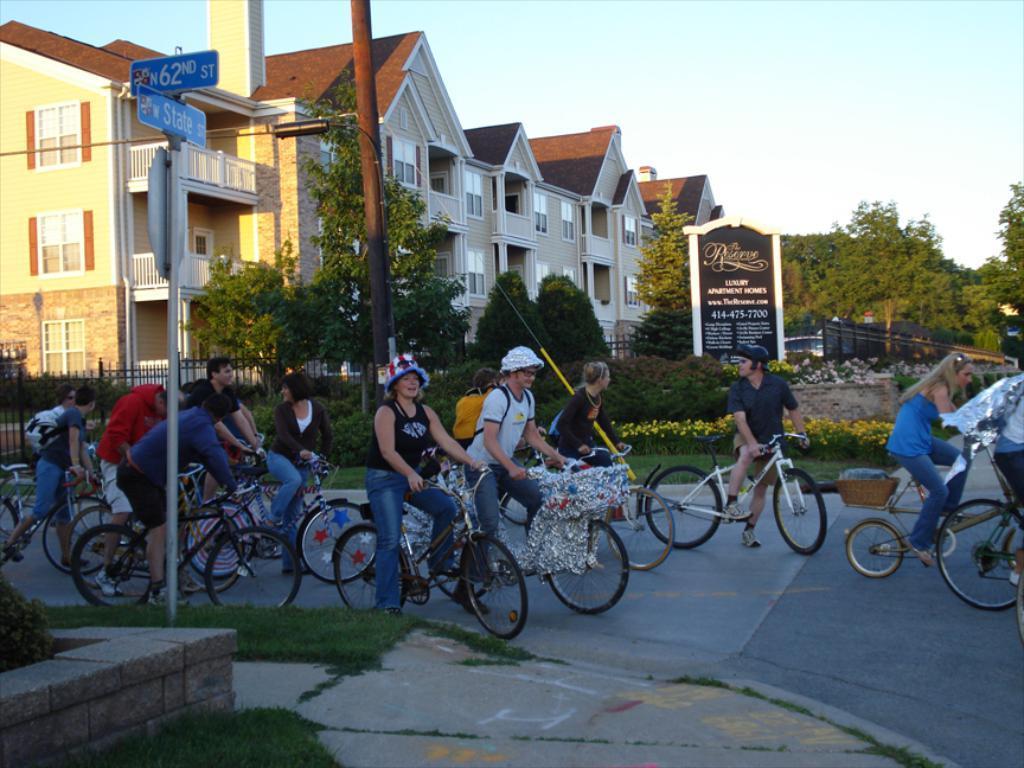Can you describe this image briefly? In the image we can see there are people who are sitting on bicycle which is on the road and there are trees and buildings on the other side. 